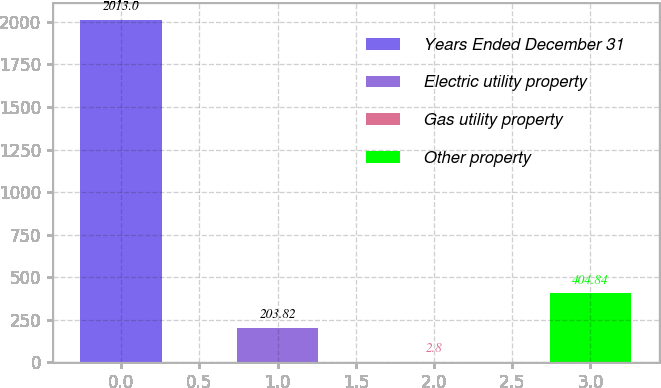<chart> <loc_0><loc_0><loc_500><loc_500><bar_chart><fcel>Years Ended December 31<fcel>Electric utility property<fcel>Gas utility property<fcel>Other property<nl><fcel>2013<fcel>203.82<fcel>2.8<fcel>404.84<nl></chart> 